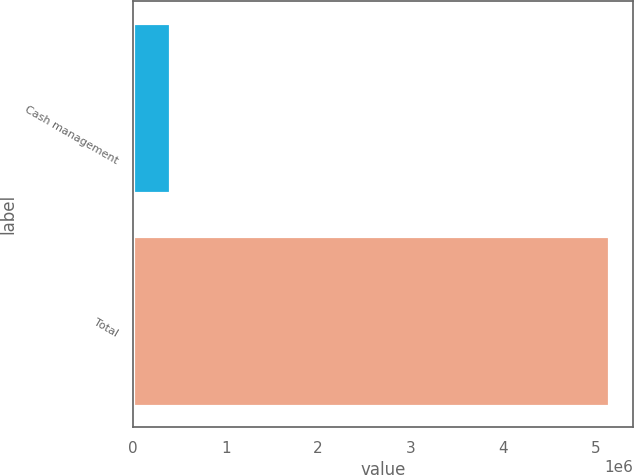Convert chart to OTSL. <chart><loc_0><loc_0><loc_500><loc_500><bar_chart><fcel>Cash management<fcel>Total<nl><fcel>403584<fcel>5.14785e+06<nl></chart> 